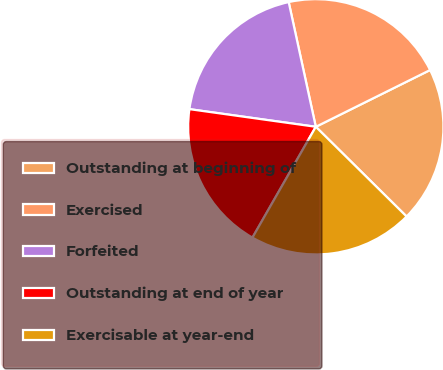<chart> <loc_0><loc_0><loc_500><loc_500><pie_chart><fcel>Outstanding at beginning of<fcel>Exercised<fcel>Forfeited<fcel>Outstanding at end of year<fcel>Exercisable at year-end<nl><fcel>19.74%<fcel>21.07%<fcel>19.38%<fcel>18.94%<fcel>20.86%<nl></chart> 